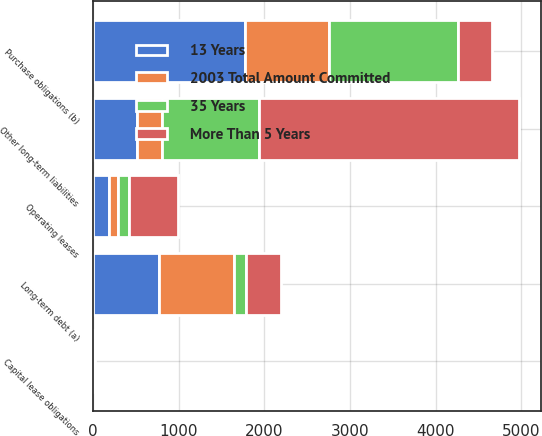Convert chart. <chart><loc_0><loc_0><loc_500><loc_500><stacked_bar_chart><ecel><fcel>Long-term debt (a)<fcel>Capital lease obligations<fcel>Operating leases<fcel>Purchase obligations (b)<fcel>Other long-term liabilities<nl><fcel>More Than 5 Years<fcel>403<fcel>10<fcel>581<fcel>403<fcel>3042<nl><fcel>35 Years<fcel>144<fcel>2<fcel>122<fcel>1508<fcel>1132<nl><fcel>13 Years<fcel>764<fcel>4<fcel>183<fcel>1774<fcel>513<nl><fcel>2003 Total Amount Committed<fcel>882<fcel>3<fcel>109<fcel>977<fcel>293<nl></chart> 